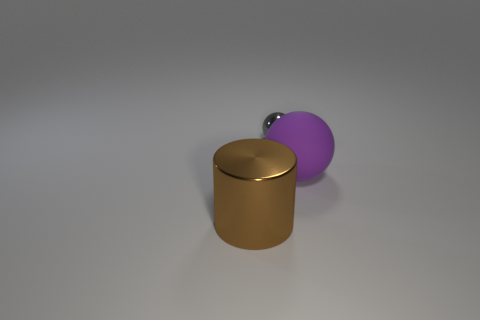How would you describe the lighting and the ambiance of the scene? The scene is lit with soft, diffused lighting, casting gentle shadows and highlighting the objects' textures. The neutral gray background contributes to a calm and minimalist ambiance, focusing attention on the objects. 